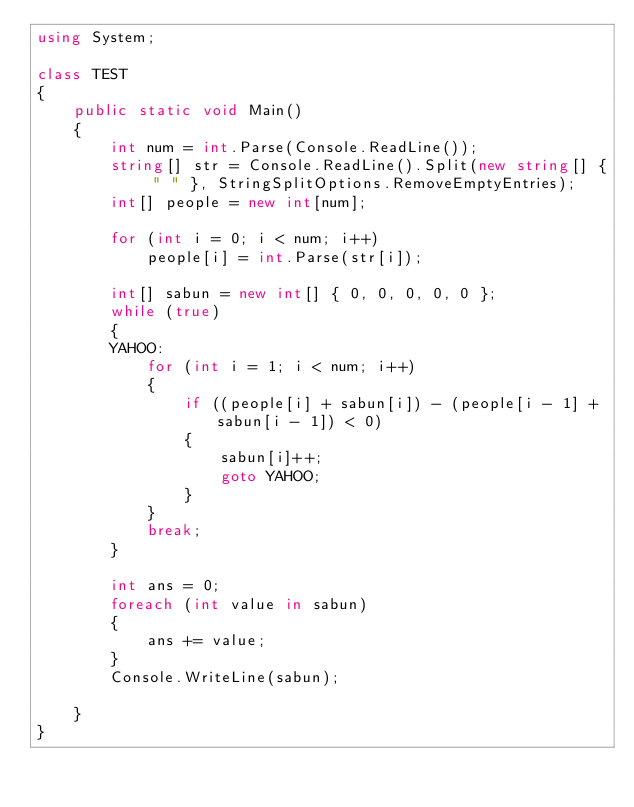Convert code to text. <code><loc_0><loc_0><loc_500><loc_500><_C#_>using System;

class TEST
{
    public static void Main()
    {
        int num = int.Parse(Console.ReadLine());
        string[] str = Console.ReadLine().Split(new string[] { " " }, StringSplitOptions.RemoveEmptyEntries);
        int[] people = new int[num];

        for (int i = 0; i < num; i++)
            people[i] = int.Parse(str[i]);

        int[] sabun = new int[] { 0, 0, 0, 0, 0 };
        while (true)
        {
        YAHOO:
            for (int i = 1; i < num; i++)
            {
                if ((people[i] + sabun[i]) - (people[i - 1] + sabun[i - 1]) < 0)
                {
                    sabun[i]++;
                    goto YAHOO;
                }
            }
            break;
        }

        int ans = 0;
        foreach (int value in sabun)
        {
            ans += value;
        }
        Console.WriteLine(sabun);

    }
}</code> 